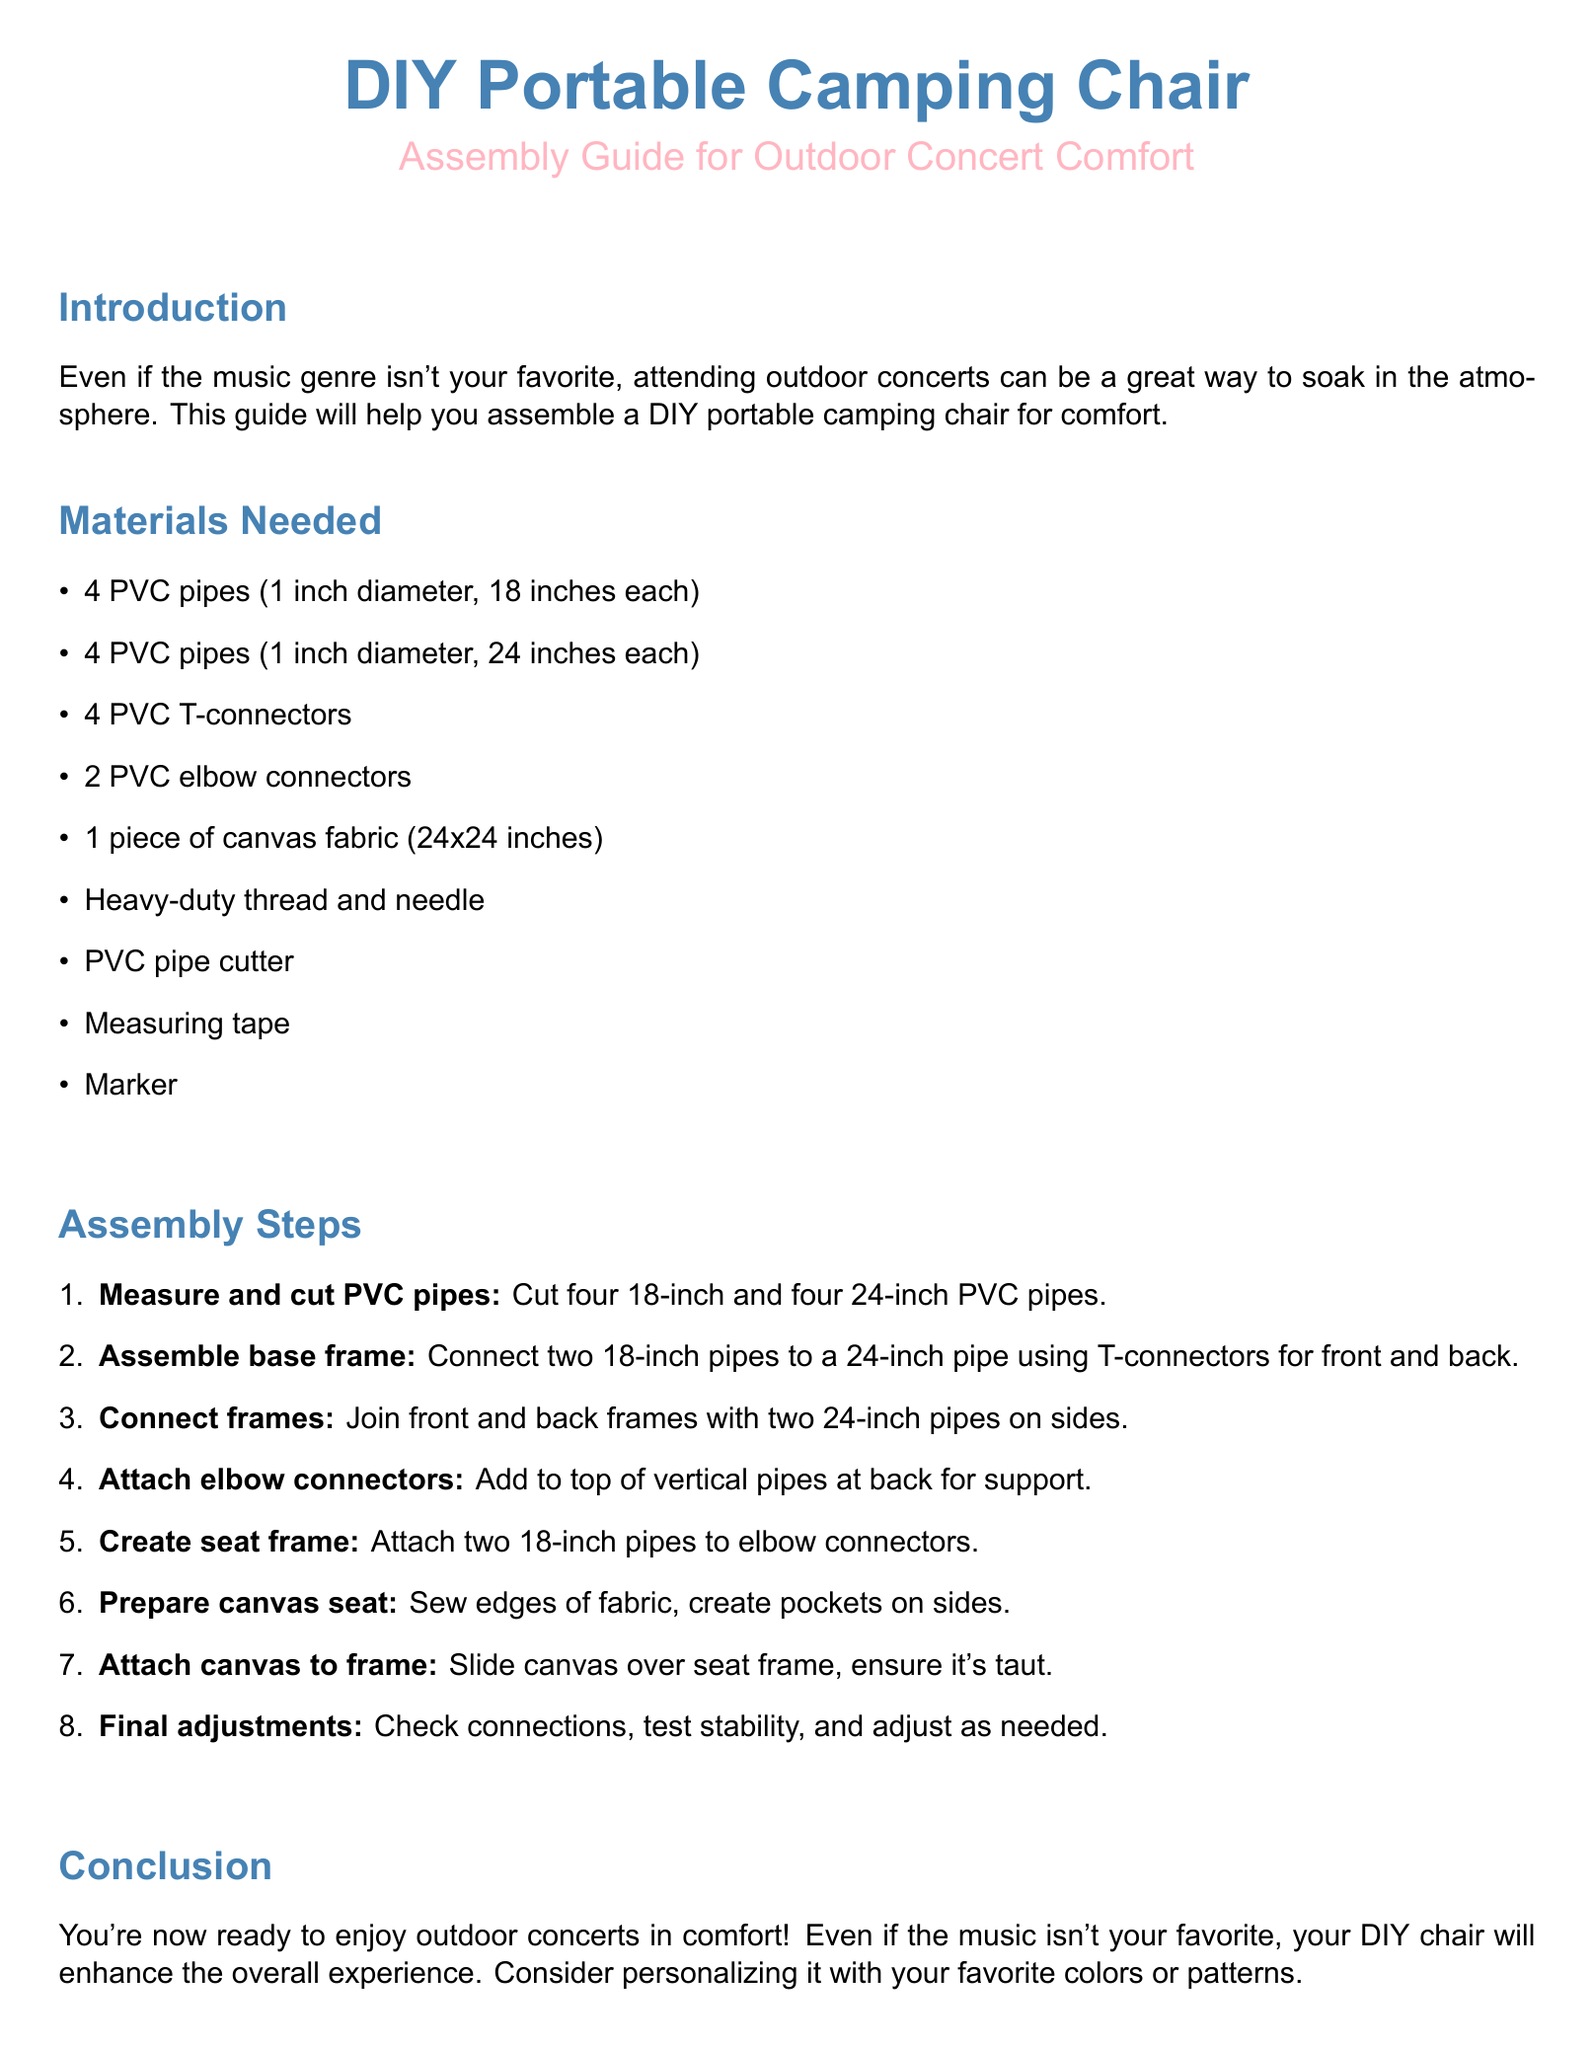What is the diameter of the PVC pipes? The document specifies that the PVC pipes have a diameter of 1 inch.
Answer: 1 inch How many PVC T-connectors are needed? According to the materials list, 4 PVC T-connectors are required for assembly.
Answer: 4 What is the size of the canvas fabric? The canvas fabric mentioned in the materials section measures 24x24 inches.
Answer: 24x24 inches What is the first step in the assembly process? The first step, as outlined in the assembly steps, is to measure and cut PVC pipes.
Answer: Measure and cut PVC pipes How many 24-inch pipes are used to connect the front and back frames? The assembly instructions state that two 24-inch pipes are used on the sides to connect the front and back frames.
Answer: 2 What is the final step described in the document? The final step involves checking all connections, testing stability, and making adjustments as necessary.
Answer: Final adjustments What type of thread is mentioned for sewing the canvas? The guide specifies using heavy-duty thread for sewing the edges of the canvas fabric.
Answer: Heavy-duty thread What type of concerts is the chair intended for? The chair is specifically designed for outdoor concerts, as stated in the introduction.
Answer: Outdoor concerts What is the purpose of adding elbow connectors? The elbow connectors are added to provide support at the top of the vertical pipes in the back frame.
Answer: Support 